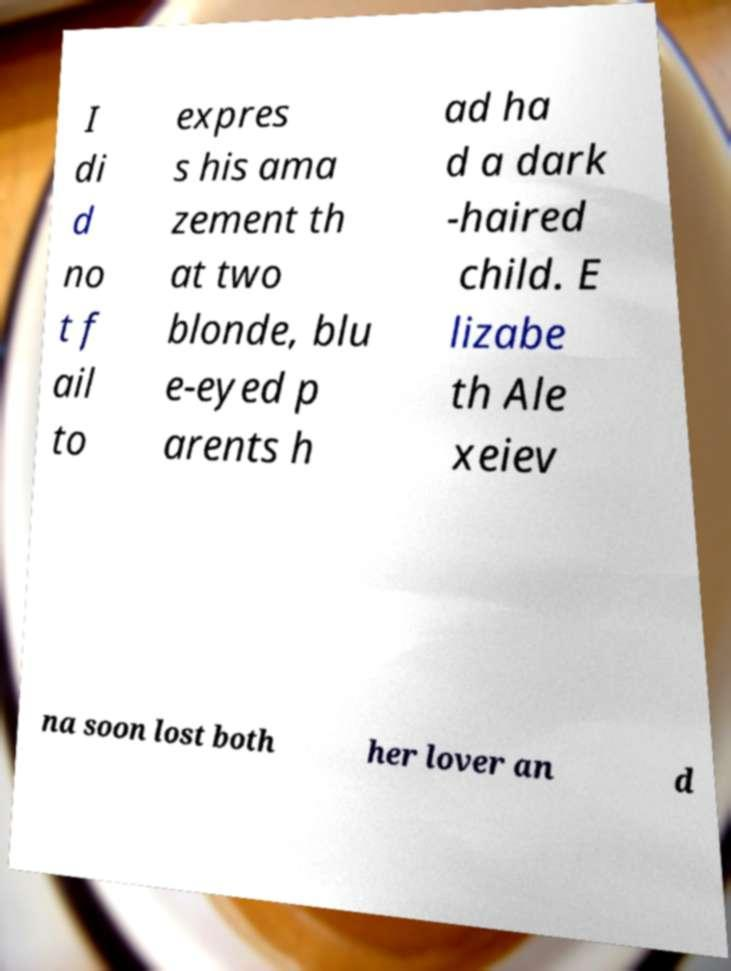Could you extract and type out the text from this image? I di d no t f ail to expres s his ama zement th at two blonde, blu e-eyed p arents h ad ha d a dark -haired child. E lizabe th Ale xeiev na soon lost both her lover an d 